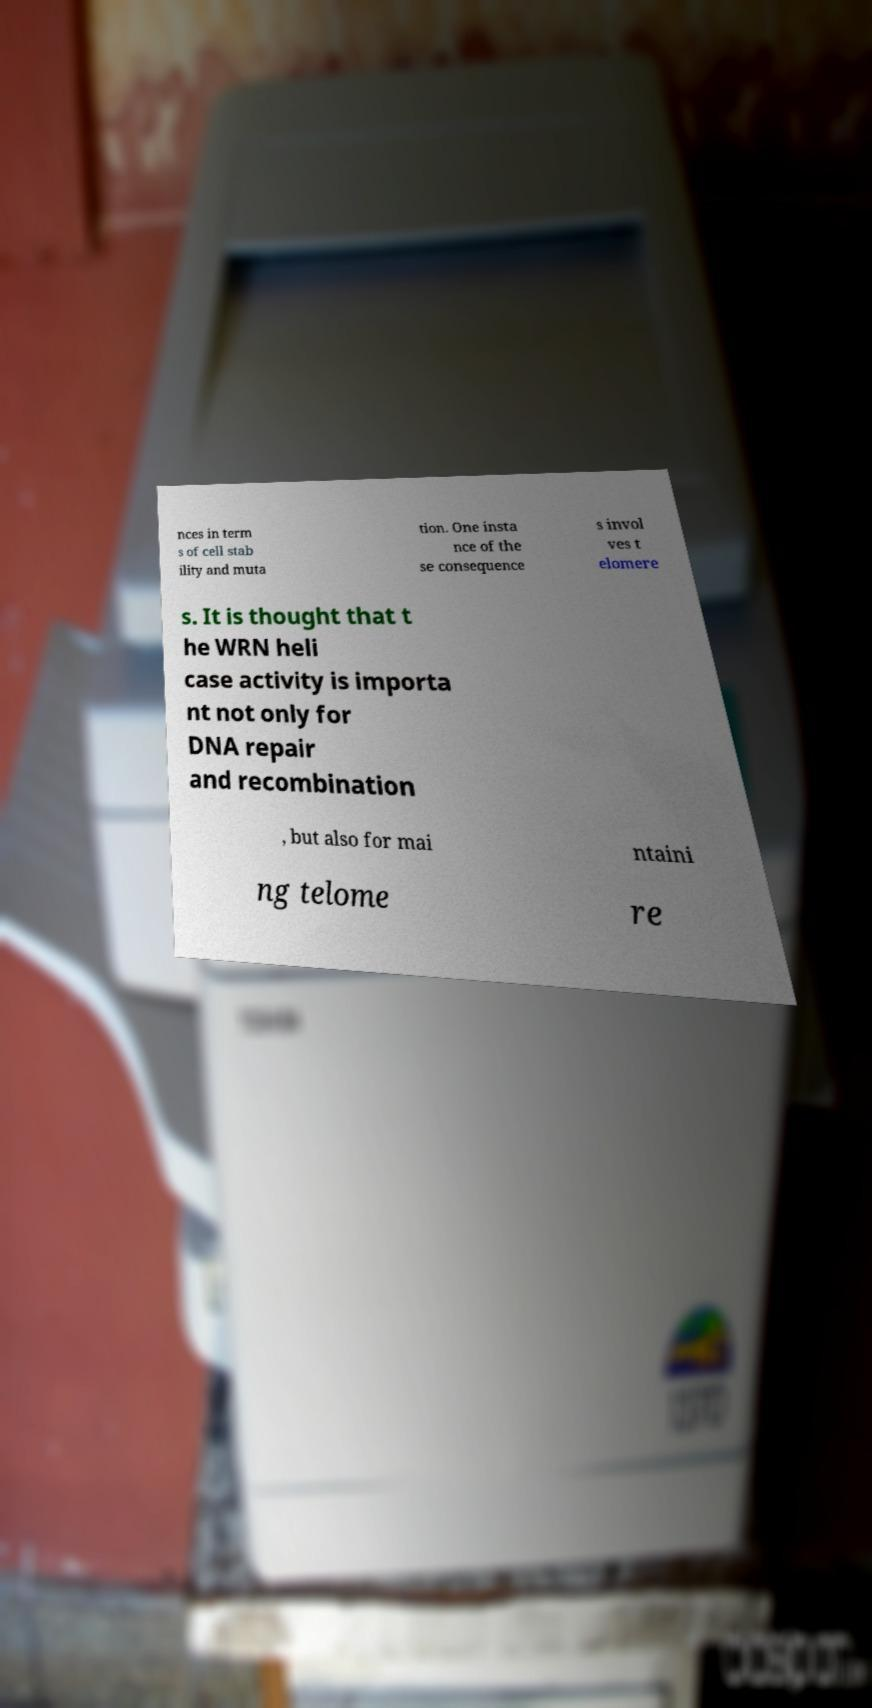I need the written content from this picture converted into text. Can you do that? nces in term s of cell stab ility and muta tion. One insta nce of the se consequence s invol ves t elomere s. It is thought that t he WRN heli case activity is importa nt not only for DNA repair and recombination , but also for mai ntaini ng telome re 